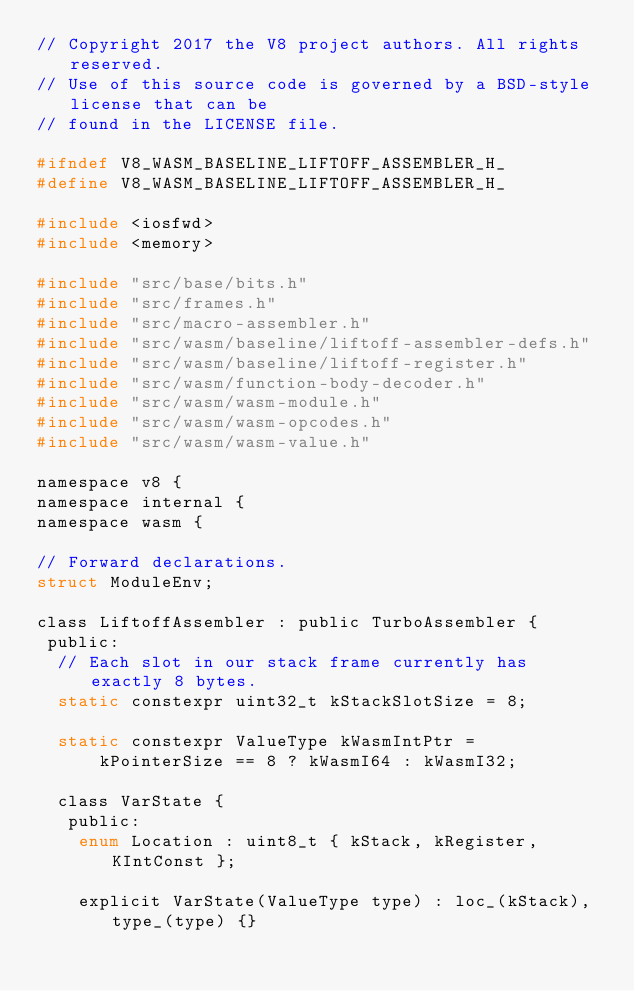Convert code to text. <code><loc_0><loc_0><loc_500><loc_500><_C_>// Copyright 2017 the V8 project authors. All rights reserved.
// Use of this source code is governed by a BSD-style license that can be
// found in the LICENSE file.

#ifndef V8_WASM_BASELINE_LIFTOFF_ASSEMBLER_H_
#define V8_WASM_BASELINE_LIFTOFF_ASSEMBLER_H_

#include <iosfwd>
#include <memory>

#include "src/base/bits.h"
#include "src/frames.h"
#include "src/macro-assembler.h"
#include "src/wasm/baseline/liftoff-assembler-defs.h"
#include "src/wasm/baseline/liftoff-register.h"
#include "src/wasm/function-body-decoder.h"
#include "src/wasm/wasm-module.h"
#include "src/wasm/wasm-opcodes.h"
#include "src/wasm/wasm-value.h"

namespace v8 {
namespace internal {
namespace wasm {

// Forward declarations.
struct ModuleEnv;

class LiftoffAssembler : public TurboAssembler {
 public:
  // Each slot in our stack frame currently has exactly 8 bytes.
  static constexpr uint32_t kStackSlotSize = 8;

  static constexpr ValueType kWasmIntPtr =
      kPointerSize == 8 ? kWasmI64 : kWasmI32;

  class VarState {
   public:
    enum Location : uint8_t { kStack, kRegister, KIntConst };

    explicit VarState(ValueType type) : loc_(kStack), type_(type) {}</code> 